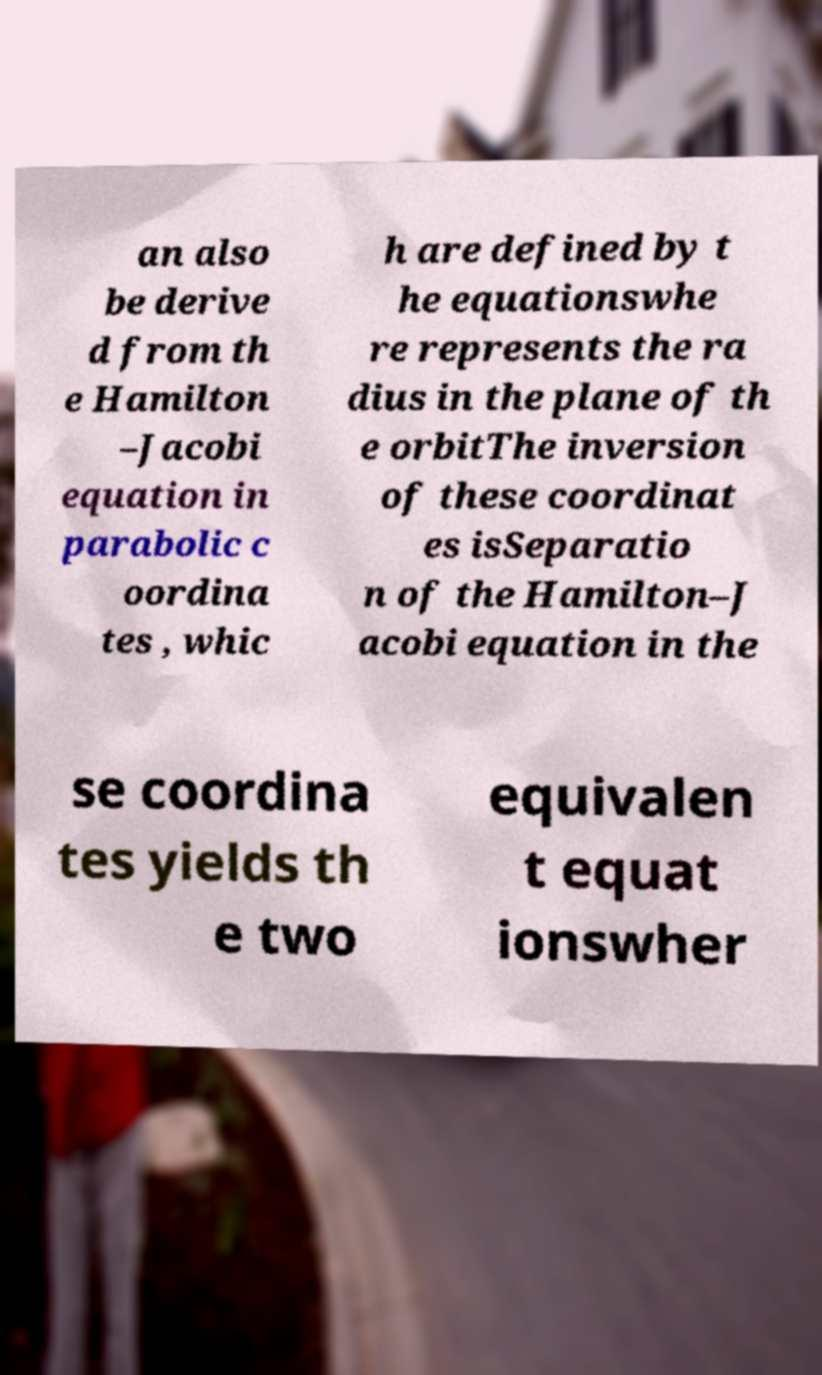There's text embedded in this image that I need extracted. Can you transcribe it verbatim? an also be derive d from th e Hamilton –Jacobi equation in parabolic c oordina tes , whic h are defined by t he equationswhe re represents the ra dius in the plane of th e orbitThe inversion of these coordinat es isSeparatio n of the Hamilton–J acobi equation in the se coordina tes yields th e two equivalen t equat ionswher 